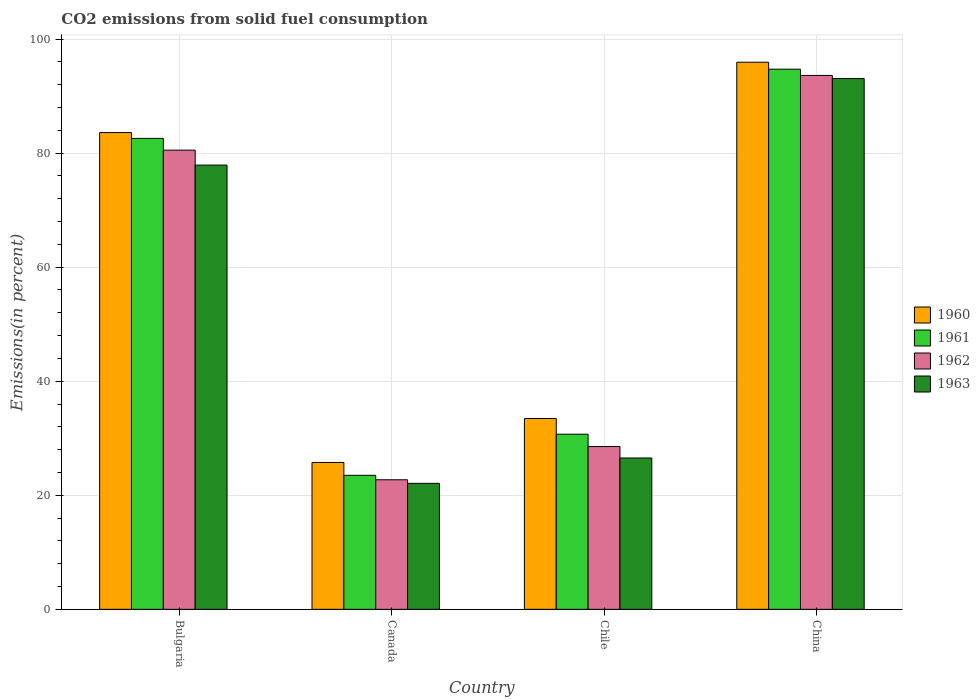How many different coloured bars are there?
Offer a very short reply. 4. How many groups of bars are there?
Your response must be concise. 4. Are the number of bars per tick equal to the number of legend labels?
Provide a short and direct response. Yes. Are the number of bars on each tick of the X-axis equal?
Your answer should be compact. Yes. How many bars are there on the 2nd tick from the left?
Offer a terse response. 4. How many bars are there on the 1st tick from the right?
Ensure brevity in your answer.  4. What is the label of the 3rd group of bars from the left?
Give a very brief answer. Chile. In how many cases, is the number of bars for a given country not equal to the number of legend labels?
Your response must be concise. 0. What is the total CO2 emitted in 1960 in Canada?
Give a very brief answer. 25.75. Across all countries, what is the maximum total CO2 emitted in 1963?
Your answer should be very brief. 93.08. Across all countries, what is the minimum total CO2 emitted in 1963?
Offer a very short reply. 22.09. In which country was the total CO2 emitted in 1960 maximum?
Provide a short and direct response. China. In which country was the total CO2 emitted in 1962 minimum?
Your response must be concise. Canada. What is the total total CO2 emitted in 1962 in the graph?
Give a very brief answer. 225.4. What is the difference between the total CO2 emitted in 1960 in Canada and that in China?
Provide a succinct answer. -70.18. What is the difference between the total CO2 emitted in 1961 in China and the total CO2 emitted in 1960 in Canada?
Provide a succinct answer. 68.96. What is the average total CO2 emitted in 1960 per country?
Offer a very short reply. 59.69. What is the difference between the total CO2 emitted of/in 1960 and total CO2 emitted of/in 1962 in Bulgaria?
Provide a succinct answer. 3.08. What is the ratio of the total CO2 emitted in 1963 in Canada to that in Chile?
Provide a succinct answer. 0.83. Is the total CO2 emitted in 1960 in Bulgaria less than that in Chile?
Keep it short and to the point. No. Is the difference between the total CO2 emitted in 1960 in Bulgaria and Canada greater than the difference between the total CO2 emitted in 1962 in Bulgaria and Canada?
Offer a very short reply. Yes. What is the difference between the highest and the second highest total CO2 emitted in 1962?
Provide a succinct answer. 51.97. What is the difference between the highest and the lowest total CO2 emitted in 1961?
Offer a terse response. 71.22. Is the sum of the total CO2 emitted in 1963 in Bulgaria and Canada greater than the maximum total CO2 emitted in 1961 across all countries?
Offer a very short reply. Yes. Is it the case that in every country, the sum of the total CO2 emitted in 1962 and total CO2 emitted in 1961 is greater than the sum of total CO2 emitted in 1963 and total CO2 emitted in 1960?
Your answer should be compact. No. What does the 2nd bar from the left in Canada represents?
Give a very brief answer. 1961. What does the 3rd bar from the right in China represents?
Provide a succinct answer. 1961. How many bars are there?
Offer a very short reply. 16. How many countries are there in the graph?
Offer a very short reply. 4. Are the values on the major ticks of Y-axis written in scientific E-notation?
Provide a short and direct response. No. Does the graph contain any zero values?
Ensure brevity in your answer.  No. Does the graph contain grids?
Give a very brief answer. Yes. How many legend labels are there?
Make the answer very short. 4. What is the title of the graph?
Your response must be concise. CO2 emissions from solid fuel consumption. What is the label or title of the X-axis?
Offer a very short reply. Country. What is the label or title of the Y-axis?
Provide a short and direct response. Emissions(in percent). What is the Emissions(in percent) in 1960 in Bulgaria?
Your answer should be compact. 83.6. What is the Emissions(in percent) in 1961 in Bulgaria?
Give a very brief answer. 82.58. What is the Emissions(in percent) of 1962 in Bulgaria?
Give a very brief answer. 80.52. What is the Emissions(in percent) in 1963 in Bulgaria?
Provide a succinct answer. 77.9. What is the Emissions(in percent) in 1960 in Canada?
Provide a succinct answer. 25.75. What is the Emissions(in percent) of 1961 in Canada?
Make the answer very short. 23.5. What is the Emissions(in percent) of 1962 in Canada?
Provide a short and direct response. 22.72. What is the Emissions(in percent) in 1963 in Canada?
Your answer should be very brief. 22.09. What is the Emissions(in percent) in 1960 in Chile?
Your response must be concise. 33.46. What is the Emissions(in percent) of 1961 in Chile?
Offer a terse response. 30.71. What is the Emissions(in percent) of 1962 in Chile?
Keep it short and to the point. 28.55. What is the Emissions(in percent) of 1963 in Chile?
Your answer should be very brief. 26.54. What is the Emissions(in percent) in 1960 in China?
Keep it short and to the point. 95.93. What is the Emissions(in percent) of 1961 in China?
Keep it short and to the point. 94.72. What is the Emissions(in percent) of 1962 in China?
Provide a succinct answer. 93.62. What is the Emissions(in percent) in 1963 in China?
Provide a short and direct response. 93.08. Across all countries, what is the maximum Emissions(in percent) in 1960?
Offer a terse response. 95.93. Across all countries, what is the maximum Emissions(in percent) in 1961?
Provide a short and direct response. 94.72. Across all countries, what is the maximum Emissions(in percent) in 1962?
Offer a terse response. 93.62. Across all countries, what is the maximum Emissions(in percent) of 1963?
Offer a terse response. 93.08. Across all countries, what is the minimum Emissions(in percent) of 1960?
Provide a short and direct response. 25.75. Across all countries, what is the minimum Emissions(in percent) in 1961?
Keep it short and to the point. 23.5. Across all countries, what is the minimum Emissions(in percent) in 1962?
Offer a very short reply. 22.72. Across all countries, what is the minimum Emissions(in percent) in 1963?
Make the answer very short. 22.09. What is the total Emissions(in percent) in 1960 in the graph?
Provide a short and direct response. 238.75. What is the total Emissions(in percent) of 1961 in the graph?
Your answer should be very brief. 231.5. What is the total Emissions(in percent) in 1962 in the graph?
Provide a short and direct response. 225.4. What is the total Emissions(in percent) of 1963 in the graph?
Ensure brevity in your answer.  219.6. What is the difference between the Emissions(in percent) of 1960 in Bulgaria and that in Canada?
Offer a terse response. 57.85. What is the difference between the Emissions(in percent) in 1961 in Bulgaria and that in Canada?
Give a very brief answer. 59.08. What is the difference between the Emissions(in percent) of 1962 in Bulgaria and that in Canada?
Offer a terse response. 57.8. What is the difference between the Emissions(in percent) in 1963 in Bulgaria and that in Canada?
Ensure brevity in your answer.  55.81. What is the difference between the Emissions(in percent) of 1960 in Bulgaria and that in Chile?
Make the answer very short. 50.14. What is the difference between the Emissions(in percent) in 1961 in Bulgaria and that in Chile?
Keep it short and to the point. 51.87. What is the difference between the Emissions(in percent) in 1962 in Bulgaria and that in Chile?
Offer a very short reply. 51.97. What is the difference between the Emissions(in percent) in 1963 in Bulgaria and that in Chile?
Your answer should be very brief. 51.36. What is the difference between the Emissions(in percent) in 1960 in Bulgaria and that in China?
Ensure brevity in your answer.  -12.33. What is the difference between the Emissions(in percent) of 1961 in Bulgaria and that in China?
Ensure brevity in your answer.  -12.14. What is the difference between the Emissions(in percent) in 1962 in Bulgaria and that in China?
Provide a succinct answer. -13.1. What is the difference between the Emissions(in percent) of 1963 in Bulgaria and that in China?
Offer a terse response. -15.18. What is the difference between the Emissions(in percent) in 1960 in Canada and that in Chile?
Your answer should be very brief. -7.71. What is the difference between the Emissions(in percent) in 1961 in Canada and that in Chile?
Provide a short and direct response. -7.21. What is the difference between the Emissions(in percent) of 1962 in Canada and that in Chile?
Provide a short and direct response. -5.83. What is the difference between the Emissions(in percent) of 1963 in Canada and that in Chile?
Make the answer very short. -4.45. What is the difference between the Emissions(in percent) of 1960 in Canada and that in China?
Provide a succinct answer. -70.18. What is the difference between the Emissions(in percent) of 1961 in Canada and that in China?
Give a very brief answer. -71.22. What is the difference between the Emissions(in percent) in 1962 in Canada and that in China?
Provide a succinct answer. -70.9. What is the difference between the Emissions(in percent) of 1963 in Canada and that in China?
Provide a succinct answer. -70.98. What is the difference between the Emissions(in percent) of 1960 in Chile and that in China?
Give a very brief answer. -62.47. What is the difference between the Emissions(in percent) of 1961 in Chile and that in China?
Offer a terse response. -64.01. What is the difference between the Emissions(in percent) of 1962 in Chile and that in China?
Your answer should be very brief. -65.07. What is the difference between the Emissions(in percent) in 1963 in Chile and that in China?
Ensure brevity in your answer.  -66.54. What is the difference between the Emissions(in percent) of 1960 in Bulgaria and the Emissions(in percent) of 1961 in Canada?
Provide a short and direct response. 60.1. What is the difference between the Emissions(in percent) of 1960 in Bulgaria and the Emissions(in percent) of 1962 in Canada?
Offer a very short reply. 60.88. What is the difference between the Emissions(in percent) of 1960 in Bulgaria and the Emissions(in percent) of 1963 in Canada?
Your answer should be compact. 61.51. What is the difference between the Emissions(in percent) in 1961 in Bulgaria and the Emissions(in percent) in 1962 in Canada?
Keep it short and to the point. 59.86. What is the difference between the Emissions(in percent) in 1961 in Bulgaria and the Emissions(in percent) in 1963 in Canada?
Your answer should be compact. 60.49. What is the difference between the Emissions(in percent) of 1962 in Bulgaria and the Emissions(in percent) of 1963 in Canada?
Ensure brevity in your answer.  58.43. What is the difference between the Emissions(in percent) of 1960 in Bulgaria and the Emissions(in percent) of 1961 in Chile?
Your response must be concise. 52.9. What is the difference between the Emissions(in percent) of 1960 in Bulgaria and the Emissions(in percent) of 1962 in Chile?
Provide a short and direct response. 55.06. What is the difference between the Emissions(in percent) of 1960 in Bulgaria and the Emissions(in percent) of 1963 in Chile?
Your response must be concise. 57.06. What is the difference between the Emissions(in percent) of 1961 in Bulgaria and the Emissions(in percent) of 1962 in Chile?
Ensure brevity in your answer.  54.03. What is the difference between the Emissions(in percent) in 1961 in Bulgaria and the Emissions(in percent) in 1963 in Chile?
Ensure brevity in your answer.  56.04. What is the difference between the Emissions(in percent) in 1962 in Bulgaria and the Emissions(in percent) in 1963 in Chile?
Offer a very short reply. 53.98. What is the difference between the Emissions(in percent) of 1960 in Bulgaria and the Emissions(in percent) of 1961 in China?
Your answer should be compact. -11.12. What is the difference between the Emissions(in percent) in 1960 in Bulgaria and the Emissions(in percent) in 1962 in China?
Provide a succinct answer. -10.02. What is the difference between the Emissions(in percent) in 1960 in Bulgaria and the Emissions(in percent) in 1963 in China?
Your response must be concise. -9.47. What is the difference between the Emissions(in percent) of 1961 in Bulgaria and the Emissions(in percent) of 1962 in China?
Provide a short and direct response. -11.04. What is the difference between the Emissions(in percent) of 1961 in Bulgaria and the Emissions(in percent) of 1963 in China?
Give a very brief answer. -10.5. What is the difference between the Emissions(in percent) in 1962 in Bulgaria and the Emissions(in percent) in 1963 in China?
Keep it short and to the point. -12.56. What is the difference between the Emissions(in percent) of 1960 in Canada and the Emissions(in percent) of 1961 in Chile?
Offer a very short reply. -4.95. What is the difference between the Emissions(in percent) of 1960 in Canada and the Emissions(in percent) of 1962 in Chile?
Offer a very short reply. -2.79. What is the difference between the Emissions(in percent) of 1960 in Canada and the Emissions(in percent) of 1963 in Chile?
Provide a succinct answer. -0.78. What is the difference between the Emissions(in percent) in 1961 in Canada and the Emissions(in percent) in 1962 in Chile?
Provide a short and direct response. -5.05. What is the difference between the Emissions(in percent) in 1961 in Canada and the Emissions(in percent) in 1963 in Chile?
Keep it short and to the point. -3.04. What is the difference between the Emissions(in percent) in 1962 in Canada and the Emissions(in percent) in 1963 in Chile?
Provide a short and direct response. -3.82. What is the difference between the Emissions(in percent) of 1960 in Canada and the Emissions(in percent) of 1961 in China?
Offer a terse response. -68.96. What is the difference between the Emissions(in percent) in 1960 in Canada and the Emissions(in percent) in 1962 in China?
Your answer should be compact. -67.87. What is the difference between the Emissions(in percent) of 1960 in Canada and the Emissions(in percent) of 1963 in China?
Provide a succinct answer. -67.32. What is the difference between the Emissions(in percent) in 1961 in Canada and the Emissions(in percent) in 1962 in China?
Provide a short and direct response. -70.12. What is the difference between the Emissions(in percent) of 1961 in Canada and the Emissions(in percent) of 1963 in China?
Offer a terse response. -69.58. What is the difference between the Emissions(in percent) in 1962 in Canada and the Emissions(in percent) in 1963 in China?
Ensure brevity in your answer.  -70.36. What is the difference between the Emissions(in percent) of 1960 in Chile and the Emissions(in percent) of 1961 in China?
Your response must be concise. -61.26. What is the difference between the Emissions(in percent) in 1960 in Chile and the Emissions(in percent) in 1962 in China?
Ensure brevity in your answer.  -60.16. What is the difference between the Emissions(in percent) of 1960 in Chile and the Emissions(in percent) of 1963 in China?
Your answer should be very brief. -59.62. What is the difference between the Emissions(in percent) of 1961 in Chile and the Emissions(in percent) of 1962 in China?
Ensure brevity in your answer.  -62.91. What is the difference between the Emissions(in percent) in 1961 in Chile and the Emissions(in percent) in 1963 in China?
Offer a terse response. -62.37. What is the difference between the Emissions(in percent) of 1962 in Chile and the Emissions(in percent) of 1963 in China?
Your answer should be compact. -64.53. What is the average Emissions(in percent) in 1960 per country?
Provide a succinct answer. 59.69. What is the average Emissions(in percent) of 1961 per country?
Provide a short and direct response. 57.88. What is the average Emissions(in percent) of 1962 per country?
Your answer should be compact. 56.35. What is the average Emissions(in percent) of 1963 per country?
Ensure brevity in your answer.  54.9. What is the difference between the Emissions(in percent) of 1960 and Emissions(in percent) of 1962 in Bulgaria?
Offer a very short reply. 3.08. What is the difference between the Emissions(in percent) in 1960 and Emissions(in percent) in 1963 in Bulgaria?
Ensure brevity in your answer.  5.7. What is the difference between the Emissions(in percent) of 1961 and Emissions(in percent) of 1962 in Bulgaria?
Give a very brief answer. 2.06. What is the difference between the Emissions(in percent) in 1961 and Emissions(in percent) in 1963 in Bulgaria?
Offer a very short reply. 4.68. What is the difference between the Emissions(in percent) in 1962 and Emissions(in percent) in 1963 in Bulgaria?
Offer a very short reply. 2.62. What is the difference between the Emissions(in percent) of 1960 and Emissions(in percent) of 1961 in Canada?
Your answer should be compact. 2.25. What is the difference between the Emissions(in percent) of 1960 and Emissions(in percent) of 1962 in Canada?
Offer a very short reply. 3.03. What is the difference between the Emissions(in percent) in 1960 and Emissions(in percent) in 1963 in Canada?
Offer a terse response. 3.66. What is the difference between the Emissions(in percent) in 1961 and Emissions(in percent) in 1962 in Canada?
Offer a terse response. 0.78. What is the difference between the Emissions(in percent) of 1961 and Emissions(in percent) of 1963 in Canada?
Ensure brevity in your answer.  1.41. What is the difference between the Emissions(in percent) of 1962 and Emissions(in percent) of 1963 in Canada?
Keep it short and to the point. 0.63. What is the difference between the Emissions(in percent) in 1960 and Emissions(in percent) in 1961 in Chile?
Your answer should be compact. 2.75. What is the difference between the Emissions(in percent) in 1960 and Emissions(in percent) in 1962 in Chile?
Your answer should be compact. 4.91. What is the difference between the Emissions(in percent) in 1960 and Emissions(in percent) in 1963 in Chile?
Provide a succinct answer. 6.92. What is the difference between the Emissions(in percent) in 1961 and Emissions(in percent) in 1962 in Chile?
Your answer should be very brief. 2.16. What is the difference between the Emissions(in percent) of 1961 and Emissions(in percent) of 1963 in Chile?
Offer a very short reply. 4.17. What is the difference between the Emissions(in percent) in 1962 and Emissions(in percent) in 1963 in Chile?
Make the answer very short. 2.01. What is the difference between the Emissions(in percent) of 1960 and Emissions(in percent) of 1961 in China?
Your answer should be compact. 1.22. What is the difference between the Emissions(in percent) of 1960 and Emissions(in percent) of 1962 in China?
Make the answer very short. 2.32. What is the difference between the Emissions(in percent) of 1960 and Emissions(in percent) of 1963 in China?
Keep it short and to the point. 2.86. What is the difference between the Emissions(in percent) of 1961 and Emissions(in percent) of 1962 in China?
Your answer should be compact. 1.1. What is the difference between the Emissions(in percent) of 1961 and Emissions(in percent) of 1963 in China?
Provide a short and direct response. 1.64. What is the difference between the Emissions(in percent) of 1962 and Emissions(in percent) of 1963 in China?
Your answer should be very brief. 0.54. What is the ratio of the Emissions(in percent) in 1960 in Bulgaria to that in Canada?
Give a very brief answer. 3.25. What is the ratio of the Emissions(in percent) in 1961 in Bulgaria to that in Canada?
Offer a very short reply. 3.51. What is the ratio of the Emissions(in percent) in 1962 in Bulgaria to that in Canada?
Ensure brevity in your answer.  3.54. What is the ratio of the Emissions(in percent) in 1963 in Bulgaria to that in Canada?
Give a very brief answer. 3.53. What is the ratio of the Emissions(in percent) in 1960 in Bulgaria to that in Chile?
Make the answer very short. 2.5. What is the ratio of the Emissions(in percent) in 1961 in Bulgaria to that in Chile?
Your answer should be very brief. 2.69. What is the ratio of the Emissions(in percent) in 1962 in Bulgaria to that in Chile?
Your answer should be very brief. 2.82. What is the ratio of the Emissions(in percent) of 1963 in Bulgaria to that in Chile?
Provide a succinct answer. 2.94. What is the ratio of the Emissions(in percent) in 1960 in Bulgaria to that in China?
Offer a terse response. 0.87. What is the ratio of the Emissions(in percent) of 1961 in Bulgaria to that in China?
Make the answer very short. 0.87. What is the ratio of the Emissions(in percent) of 1962 in Bulgaria to that in China?
Your answer should be compact. 0.86. What is the ratio of the Emissions(in percent) in 1963 in Bulgaria to that in China?
Give a very brief answer. 0.84. What is the ratio of the Emissions(in percent) of 1960 in Canada to that in Chile?
Your response must be concise. 0.77. What is the ratio of the Emissions(in percent) in 1961 in Canada to that in Chile?
Keep it short and to the point. 0.77. What is the ratio of the Emissions(in percent) of 1962 in Canada to that in Chile?
Offer a terse response. 0.8. What is the ratio of the Emissions(in percent) in 1963 in Canada to that in Chile?
Offer a very short reply. 0.83. What is the ratio of the Emissions(in percent) in 1960 in Canada to that in China?
Make the answer very short. 0.27. What is the ratio of the Emissions(in percent) of 1961 in Canada to that in China?
Your answer should be compact. 0.25. What is the ratio of the Emissions(in percent) of 1962 in Canada to that in China?
Your answer should be very brief. 0.24. What is the ratio of the Emissions(in percent) in 1963 in Canada to that in China?
Your response must be concise. 0.24. What is the ratio of the Emissions(in percent) in 1960 in Chile to that in China?
Keep it short and to the point. 0.35. What is the ratio of the Emissions(in percent) in 1961 in Chile to that in China?
Your answer should be very brief. 0.32. What is the ratio of the Emissions(in percent) in 1962 in Chile to that in China?
Keep it short and to the point. 0.3. What is the ratio of the Emissions(in percent) in 1963 in Chile to that in China?
Provide a succinct answer. 0.29. What is the difference between the highest and the second highest Emissions(in percent) in 1960?
Offer a terse response. 12.33. What is the difference between the highest and the second highest Emissions(in percent) of 1961?
Your answer should be compact. 12.14. What is the difference between the highest and the second highest Emissions(in percent) of 1962?
Offer a terse response. 13.1. What is the difference between the highest and the second highest Emissions(in percent) of 1963?
Offer a very short reply. 15.18. What is the difference between the highest and the lowest Emissions(in percent) in 1960?
Your answer should be very brief. 70.18. What is the difference between the highest and the lowest Emissions(in percent) of 1961?
Provide a short and direct response. 71.22. What is the difference between the highest and the lowest Emissions(in percent) in 1962?
Give a very brief answer. 70.9. What is the difference between the highest and the lowest Emissions(in percent) in 1963?
Keep it short and to the point. 70.98. 